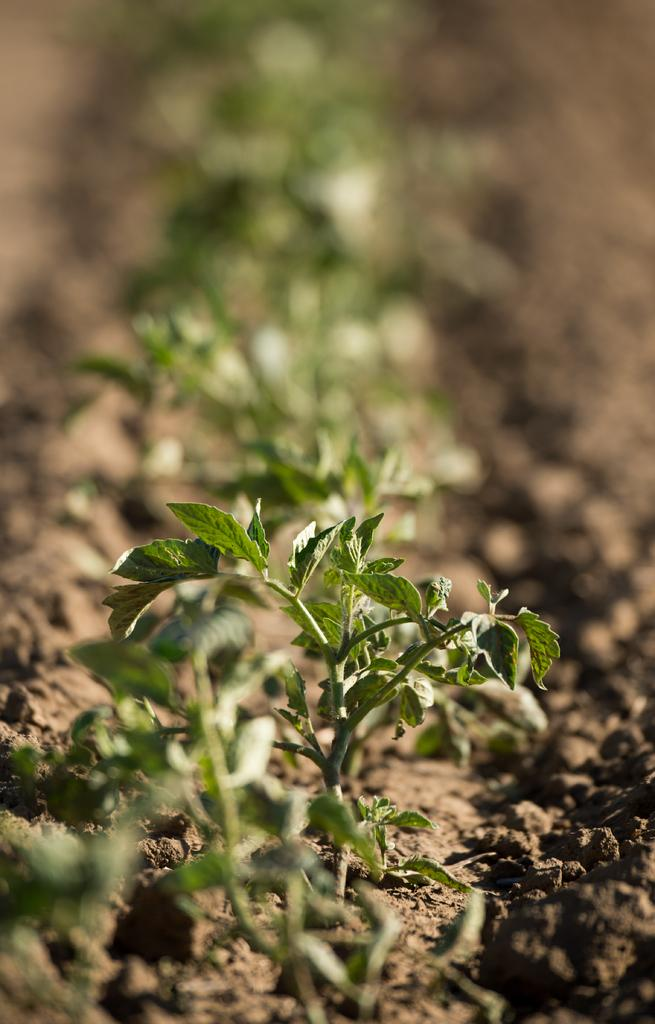What type of plants can be seen in the image? There are small plants in the image. Where are the small plants located? The small plants are present on the ground. What is the body language of the plants in the image? There are no bodies or body language present in the image, as the subject is plants. 